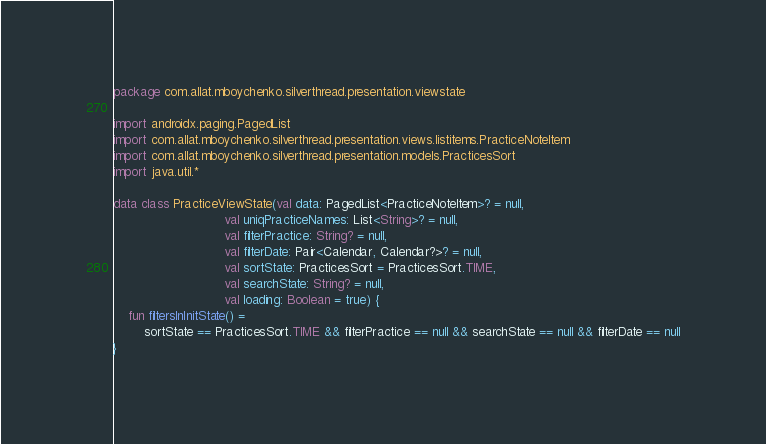Convert code to text. <code><loc_0><loc_0><loc_500><loc_500><_Kotlin_>package com.allat.mboychenko.silverthread.presentation.viewstate

import androidx.paging.PagedList
import com.allat.mboychenko.silverthread.presentation.views.listitems.PracticeNoteItem
import com.allat.mboychenko.silverthread.presentation.models.PracticesSort
import java.util.*

data class PracticeViewState(val data: PagedList<PracticeNoteItem>? = null,
                             val uniqPracticeNames: List<String>? = null,
                             val filterPractice: String? = null,
                             val filterDate: Pair<Calendar, Calendar?>? = null,
                             val sortState: PracticesSort = PracticesSort.TIME,
                             val searchState: String? = null,
                             val loading: Boolean = true) {
    fun filtersInInitState() =
        sortState == PracticesSort.TIME && filterPractice == null && searchState == null && filterDate == null
}</code> 